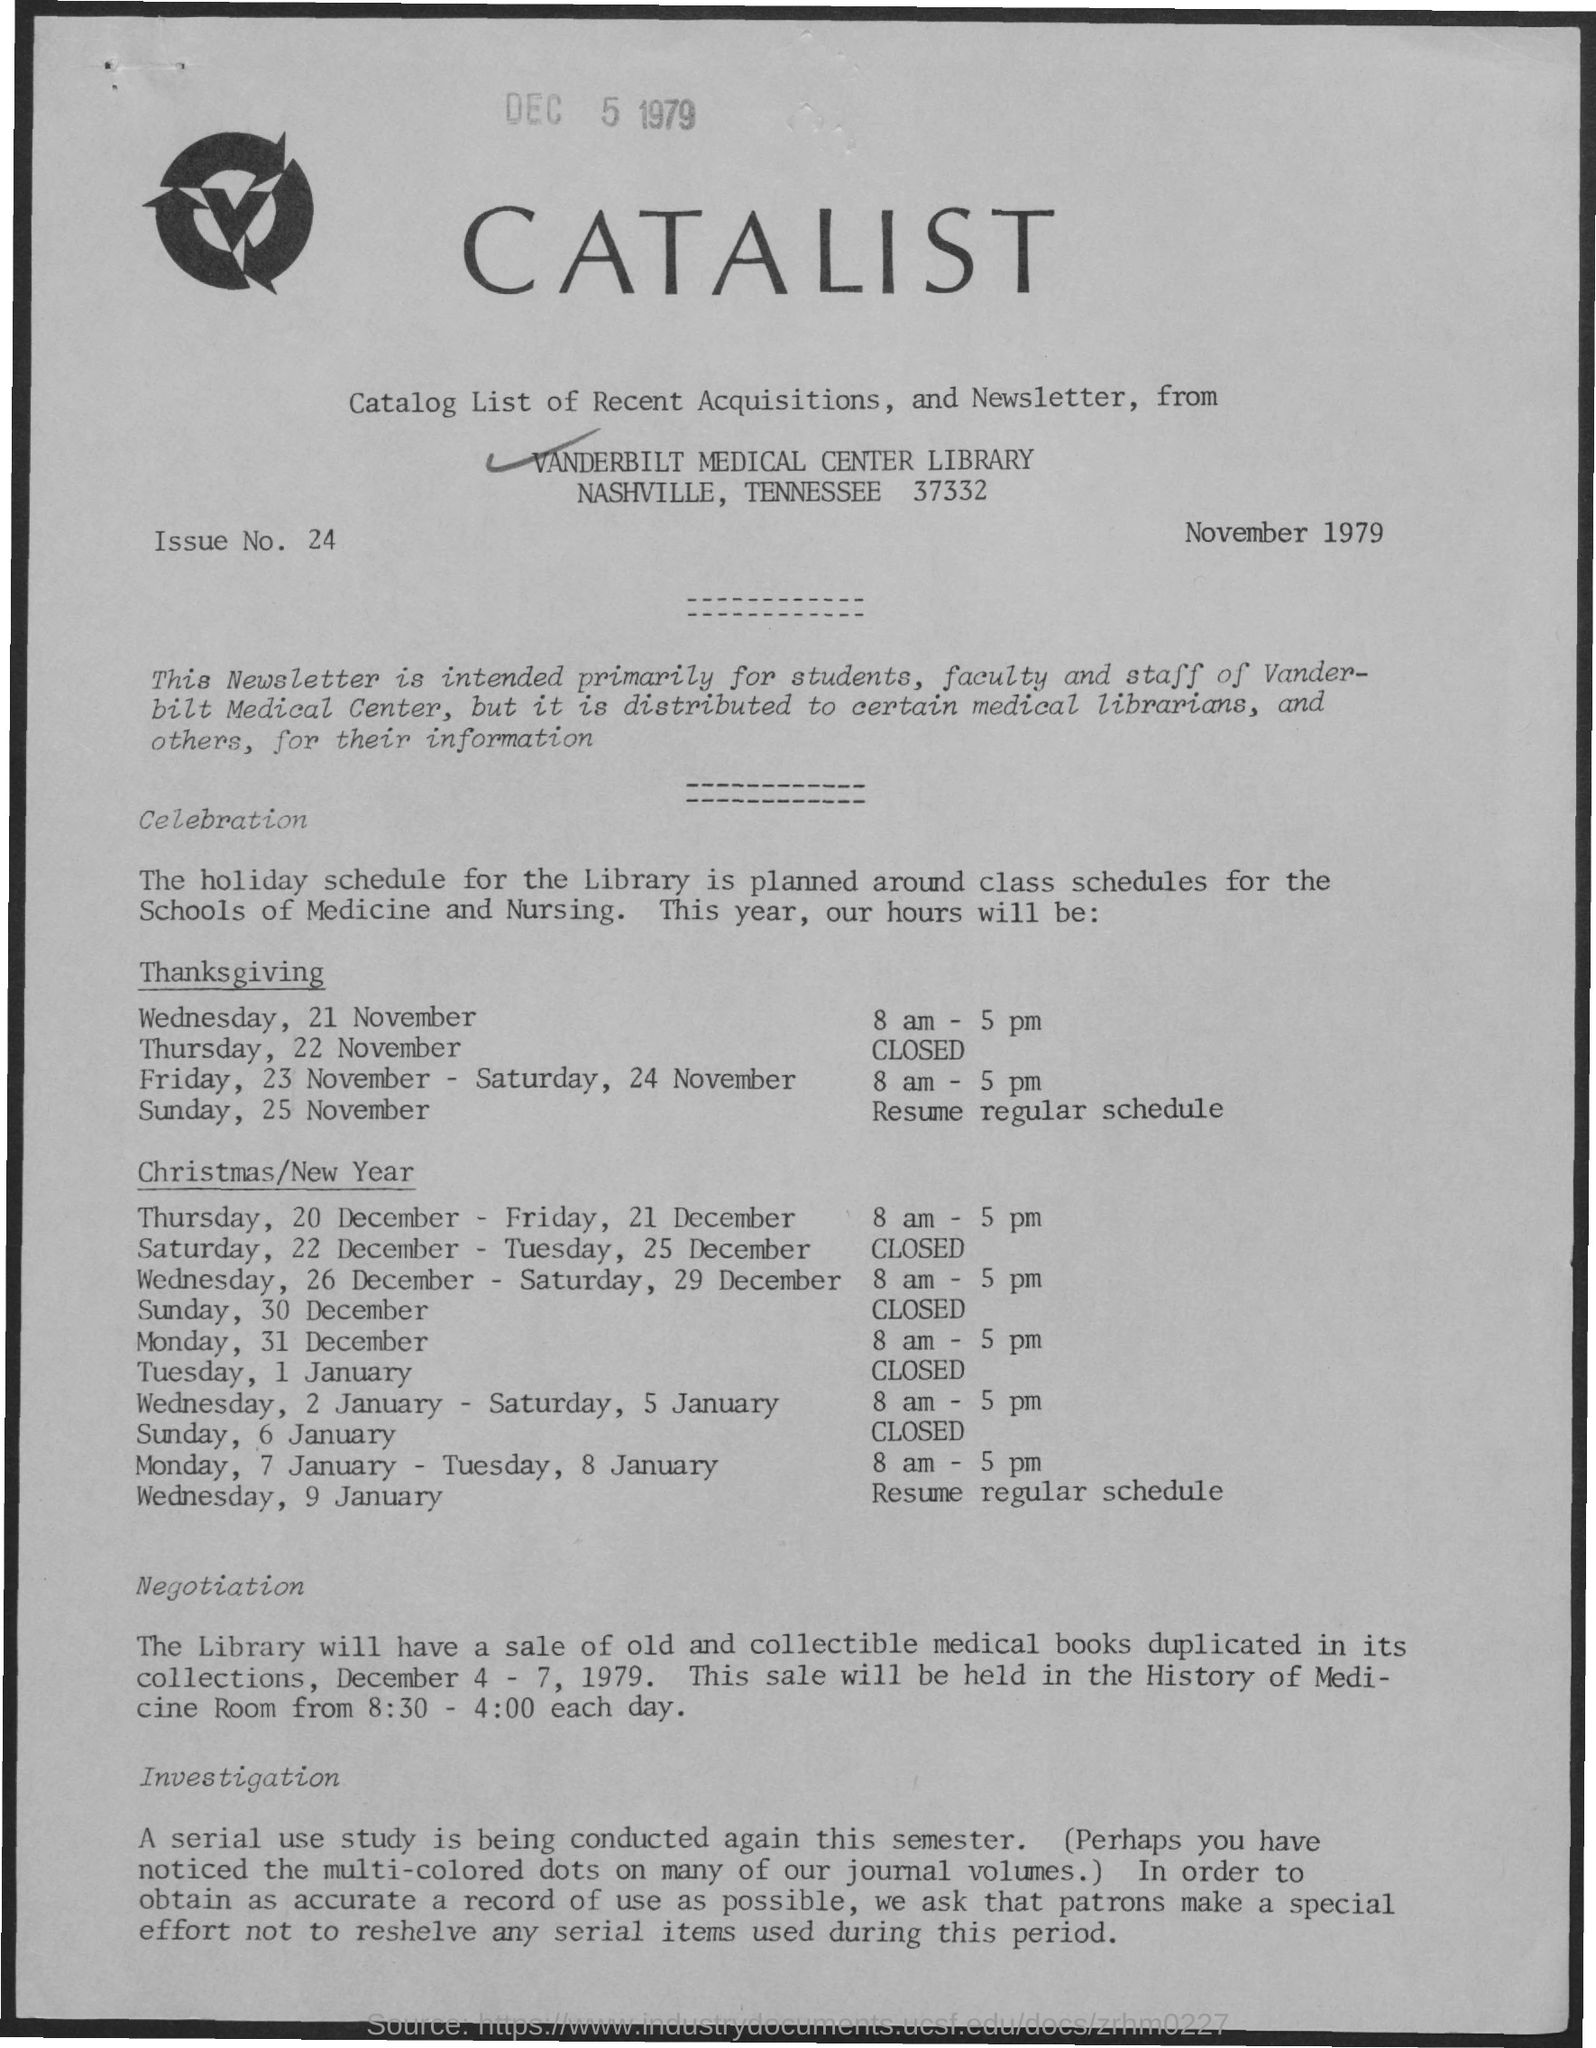Specify some key components in this picture. The issue number given in the document is 24. The document is dated November 1979. 